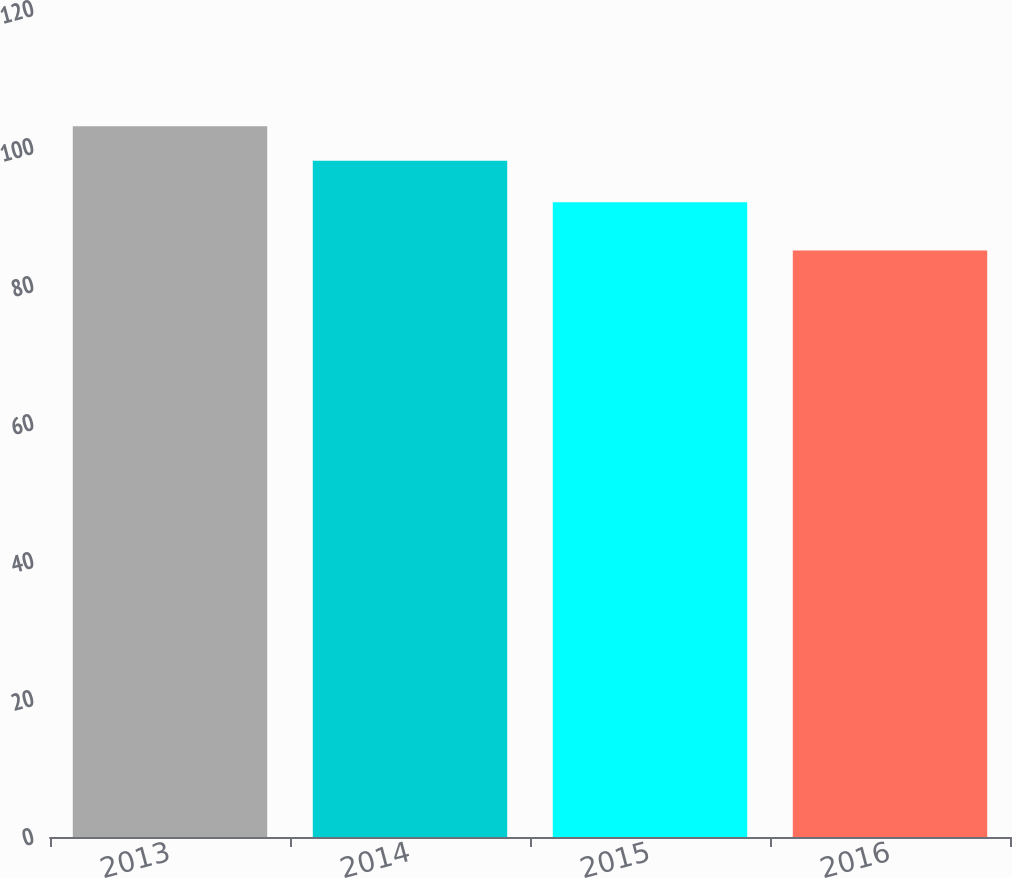Convert chart to OTSL. <chart><loc_0><loc_0><loc_500><loc_500><bar_chart><fcel>2013<fcel>2014<fcel>2015<fcel>2016<nl><fcel>103<fcel>98<fcel>92<fcel>85<nl></chart> 